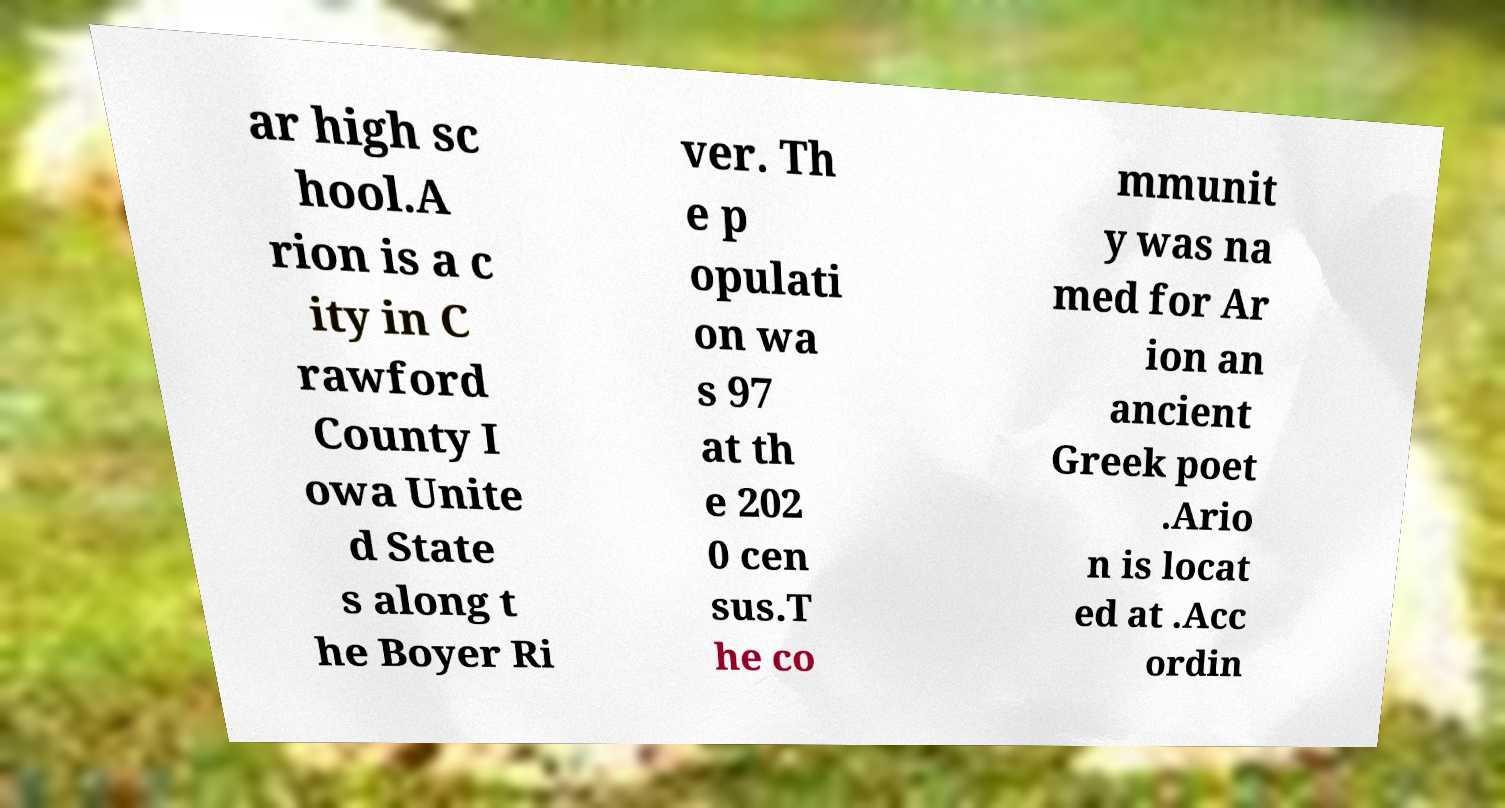There's text embedded in this image that I need extracted. Can you transcribe it verbatim? ar high sc hool.A rion is a c ity in C rawford County I owa Unite d State s along t he Boyer Ri ver. Th e p opulati on wa s 97 at th e 202 0 cen sus.T he co mmunit y was na med for Ar ion an ancient Greek poet .Ario n is locat ed at .Acc ordin 